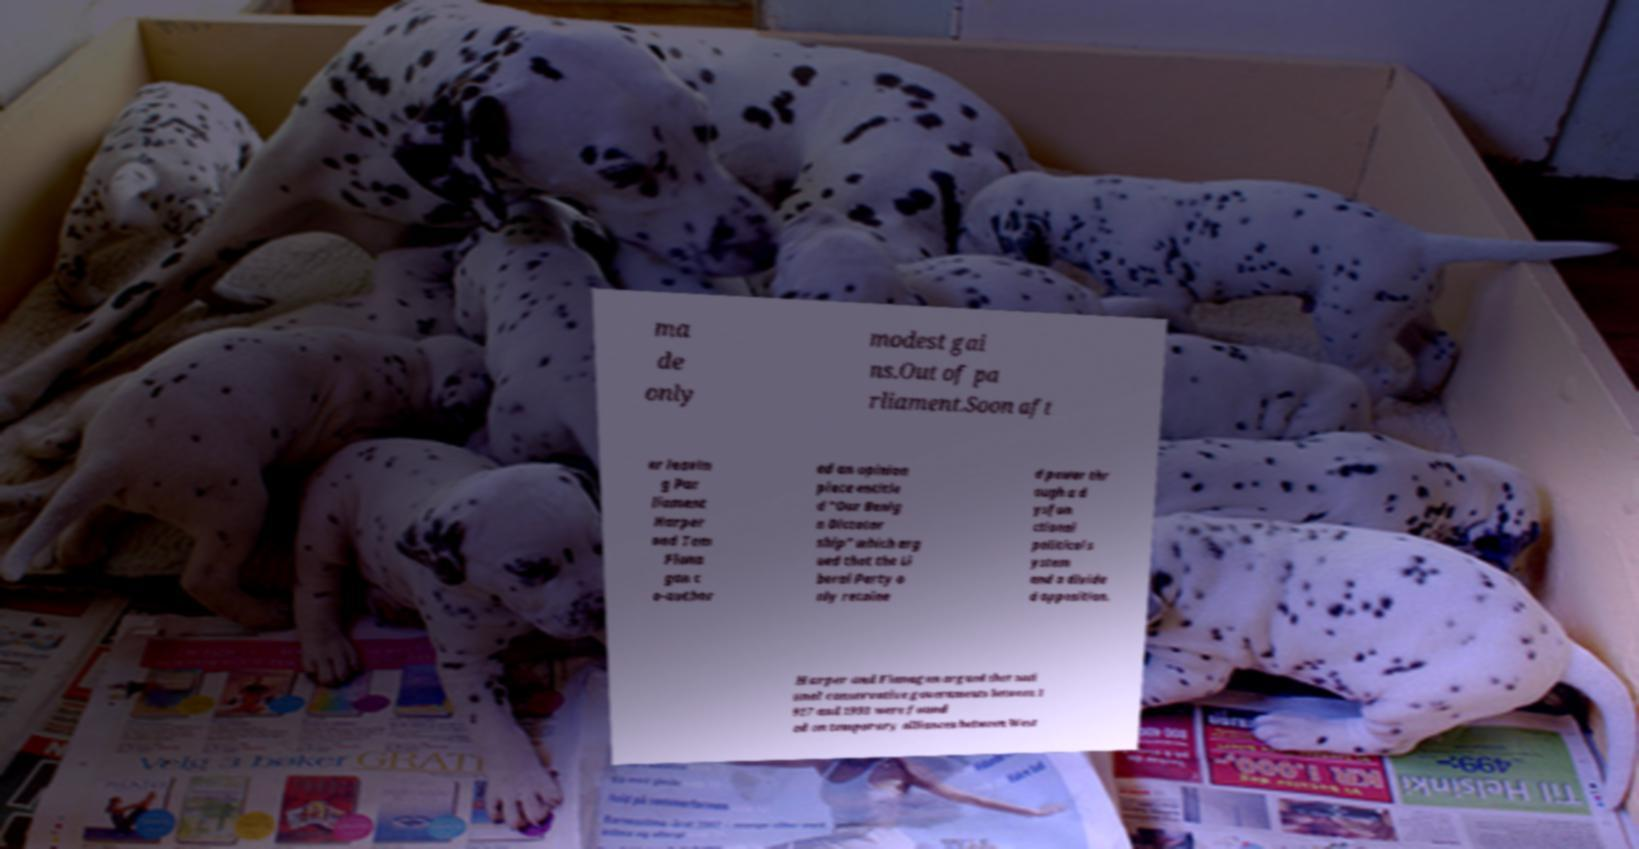For documentation purposes, I need the text within this image transcribed. Could you provide that? ma de only modest gai ns.Out of pa rliament.Soon aft er leavin g Par liament Harper and Tom Flana gan c o-author ed an opinion piece entitle d "Our Benig n Dictator ship" which arg ued that the Li beral Party o nly retaine d power thr ough a d ysfun ctional political s ystem and a divide d opposition. Harper and Flanagan argued that nati onal conservative governments between 1 917 and 1993 were found ed on temporary alliances between West 